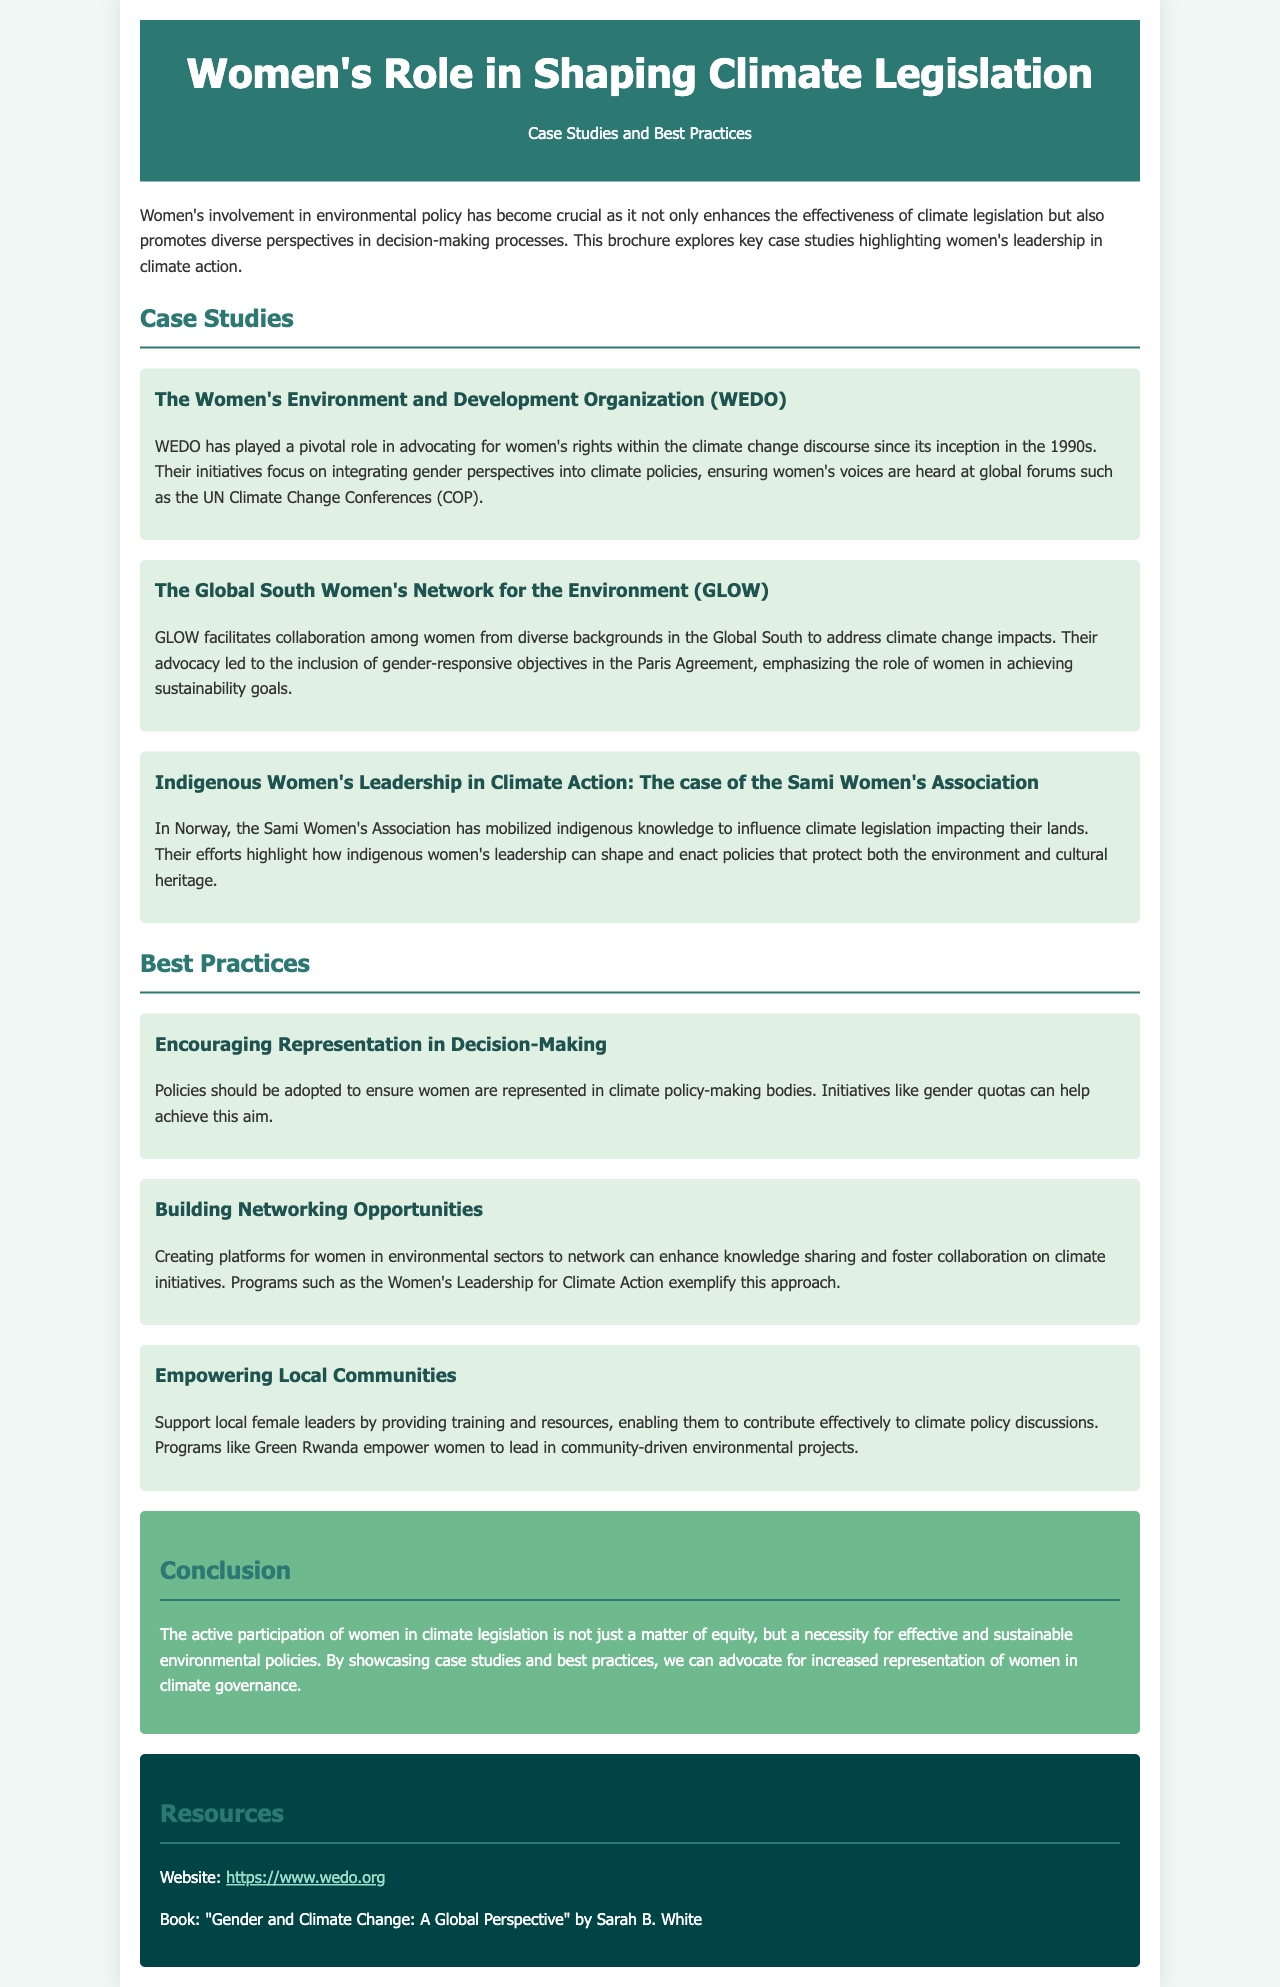What is the title of the brochure? The title is prominently displayed at the top of the document, stating the focus of the content.
Answer: Women's Role in Shaping Climate Legislation What organization is associated with advocating for women's rights in the climate change discourse? This organization is mentioned in the first case study as instrumental in integrating gender perspectives into climate policies.
Answer: WEDO When was WEDO established? The text indicates WEDO has been active since the 1990s, which provides the timeline of its operations.
Answer: 1990s What does GLOW stand for? The abbreviation is a key element within the second case study discussing the organization’s role.
Answer: Global South Women's Network for the Environment What is a proposed best practice for enhancing women's representation in climate policy? This practice is recommended to ensure women's voices are included in decision-making processes related to climate.
Answer: Gender quotas Which program empowers local female leaders in environmental projects? The document references this program as an example of supporting women's leadership in local communities.
Answer: Green Rwanda What is emphasized as necessary for effective and sustainable environmental policies? The conclusion states a critical aspect of women's involvement in climate governance.
Answer: Active participation of women What type of resources are included at the end of the brochure? This section is dedicated to providing various reference materials to further understand the topic at hand.
Answer: Websites and books 